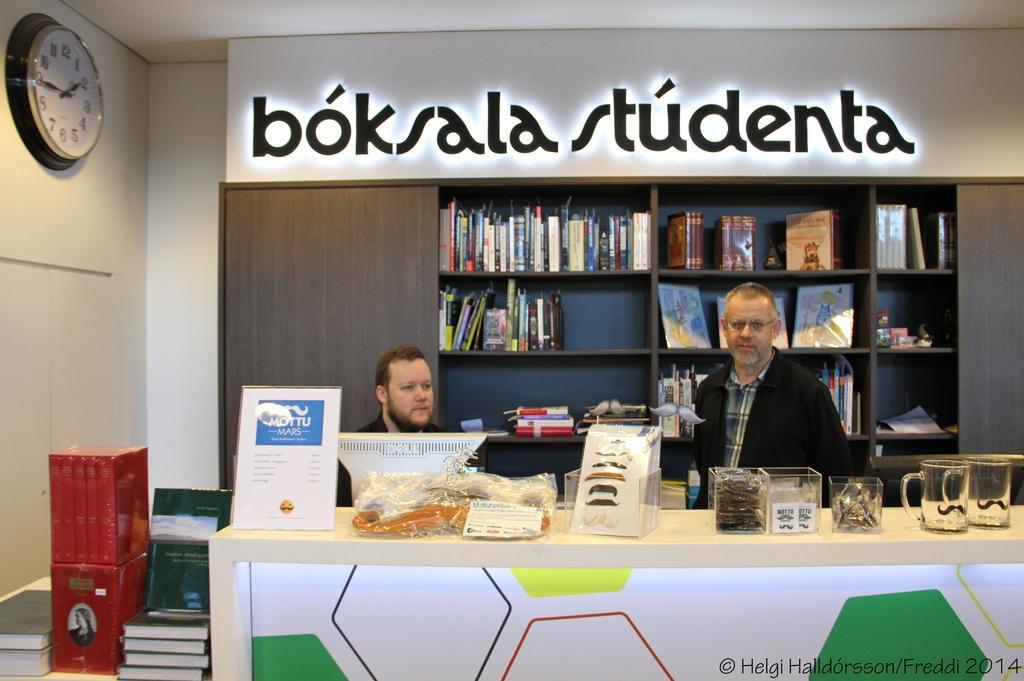Could you give a brief overview of what you see in this image? This image consists of two people and there is a table like thing on which there are glasses, boxes, card, cover. There are books on the left side, there is a wall clock in the top left corner. Behind two people there is a bookshelf and books in it. Both of them are wearing black color dress. The one who is on the left side is sitting and the one who is on the right side is standing. 